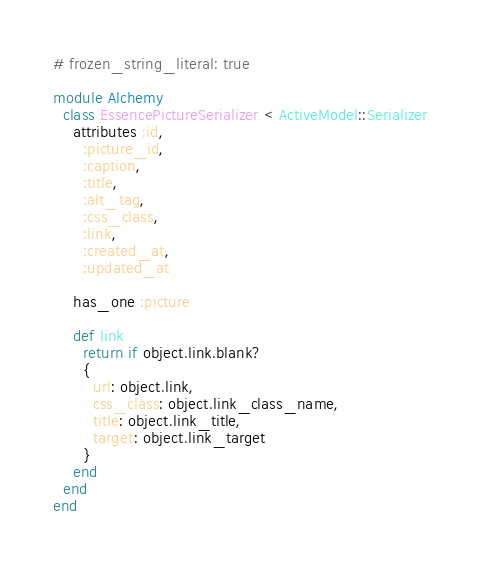<code> <loc_0><loc_0><loc_500><loc_500><_Ruby_># frozen_string_literal: true

module Alchemy
  class EssencePictureSerializer < ActiveModel::Serializer
    attributes :id,
      :picture_id,
      :caption,
      :title,
      :alt_tag,
      :css_class,
      :link,
      :created_at,
      :updated_at

    has_one :picture

    def link
      return if object.link.blank?
      {
        url: object.link,
        css_class: object.link_class_name,
        title: object.link_title,
        target: object.link_target
      }
    end
  end
end
</code> 